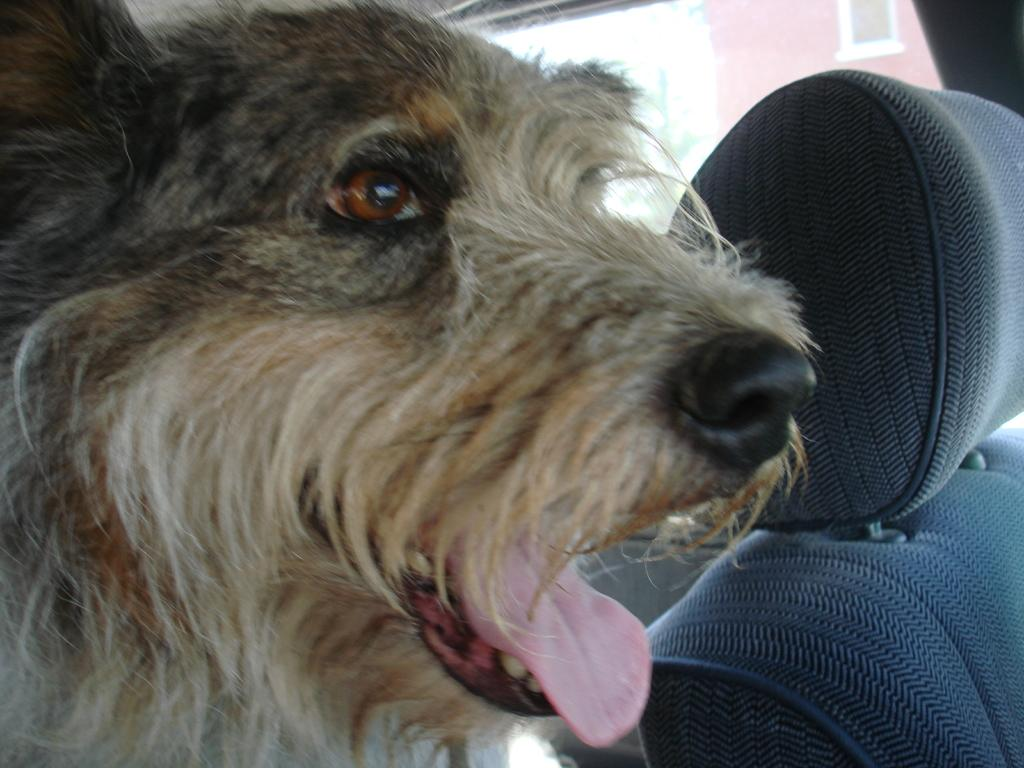What type of animal is in the image? There is a dog in the image. Where is the dog located? The dog is inside a vehicle. What can be seen in the vehicle with the dog? There is a seat visible in the image. How many oranges are hanging from the tent near the border in the image? There are no oranges, tents, or borders present in the image; it features a dog inside a vehicle with a visible seat. 